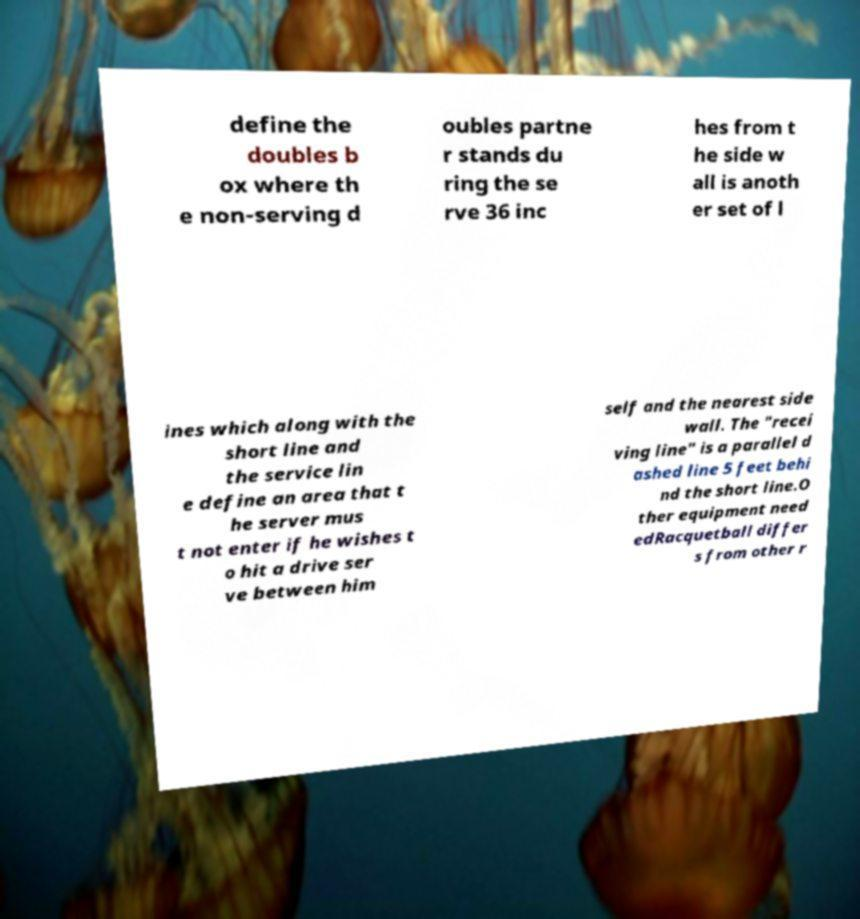Could you assist in decoding the text presented in this image and type it out clearly? define the doubles b ox where th e non-serving d oubles partne r stands du ring the se rve 36 inc hes from t he side w all is anoth er set of l ines which along with the short line and the service lin e define an area that t he server mus t not enter if he wishes t o hit a drive ser ve between him self and the nearest side wall. The "recei ving line" is a parallel d ashed line 5 feet behi nd the short line.O ther equipment need edRacquetball differ s from other r 